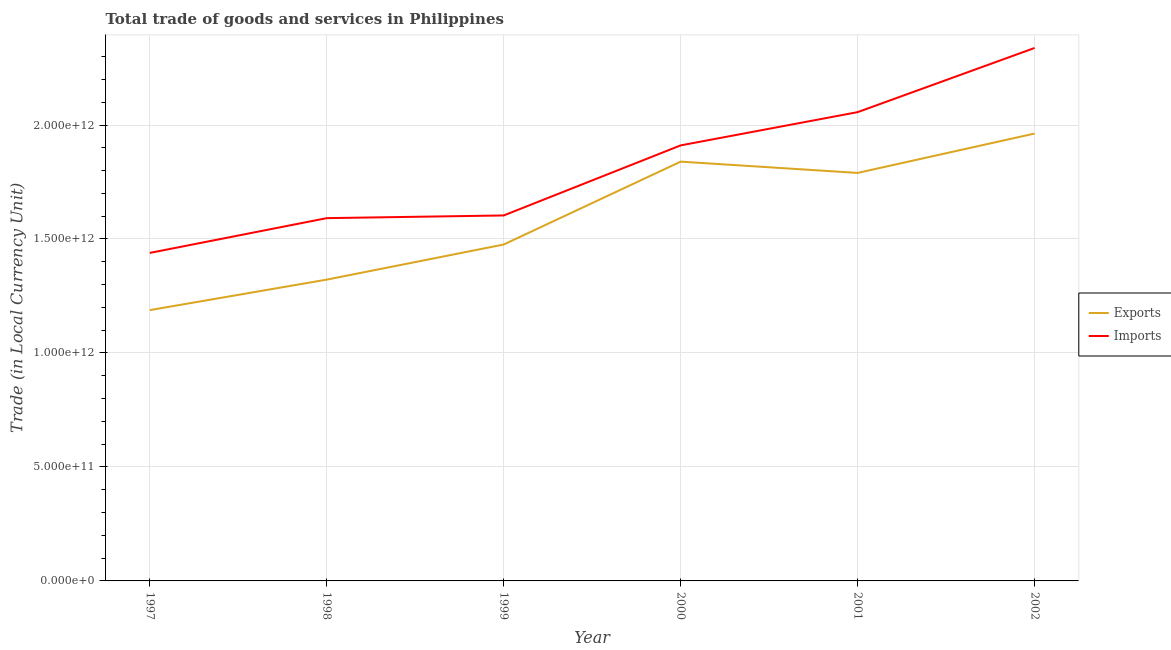How many different coloured lines are there?
Provide a short and direct response. 2. Does the line corresponding to export of goods and services intersect with the line corresponding to imports of goods and services?
Offer a terse response. No. Is the number of lines equal to the number of legend labels?
Your response must be concise. Yes. What is the imports of goods and services in 1999?
Provide a short and direct response. 1.60e+12. Across all years, what is the maximum imports of goods and services?
Provide a short and direct response. 2.34e+12. Across all years, what is the minimum export of goods and services?
Keep it short and to the point. 1.19e+12. In which year was the export of goods and services maximum?
Give a very brief answer. 2002. In which year was the export of goods and services minimum?
Your answer should be very brief. 1997. What is the total imports of goods and services in the graph?
Ensure brevity in your answer.  1.09e+13. What is the difference between the export of goods and services in 1999 and that in 2001?
Your answer should be very brief. -3.14e+11. What is the difference between the export of goods and services in 1998 and the imports of goods and services in 2002?
Your response must be concise. -1.02e+12. What is the average export of goods and services per year?
Give a very brief answer. 1.60e+12. In the year 1999, what is the difference between the export of goods and services and imports of goods and services?
Your response must be concise. -1.28e+11. In how many years, is the imports of goods and services greater than 1800000000000 LCU?
Offer a very short reply. 3. What is the ratio of the export of goods and services in 1997 to that in 2002?
Give a very brief answer. 0.61. Is the export of goods and services in 1998 less than that in 2000?
Your answer should be compact. Yes. Is the difference between the imports of goods and services in 1999 and 2001 greater than the difference between the export of goods and services in 1999 and 2001?
Give a very brief answer. No. What is the difference between the highest and the second highest imports of goods and services?
Offer a very short reply. 2.81e+11. What is the difference between the highest and the lowest imports of goods and services?
Offer a terse response. 8.99e+11. In how many years, is the export of goods and services greater than the average export of goods and services taken over all years?
Your answer should be very brief. 3. Is the imports of goods and services strictly less than the export of goods and services over the years?
Your answer should be very brief. No. What is the difference between two consecutive major ticks on the Y-axis?
Offer a very short reply. 5.00e+11. Does the graph contain any zero values?
Your answer should be very brief. No. How are the legend labels stacked?
Your response must be concise. Vertical. What is the title of the graph?
Your response must be concise. Total trade of goods and services in Philippines. Does "Import" appear as one of the legend labels in the graph?
Provide a short and direct response. No. What is the label or title of the X-axis?
Make the answer very short. Year. What is the label or title of the Y-axis?
Give a very brief answer. Trade (in Local Currency Unit). What is the Trade (in Local Currency Unit) of Exports in 1997?
Offer a very short reply. 1.19e+12. What is the Trade (in Local Currency Unit) in Imports in 1997?
Give a very brief answer. 1.44e+12. What is the Trade (in Local Currency Unit) of Exports in 1998?
Make the answer very short. 1.32e+12. What is the Trade (in Local Currency Unit) in Imports in 1998?
Give a very brief answer. 1.59e+12. What is the Trade (in Local Currency Unit) in Exports in 1999?
Your answer should be very brief. 1.48e+12. What is the Trade (in Local Currency Unit) of Imports in 1999?
Your answer should be compact. 1.60e+12. What is the Trade (in Local Currency Unit) in Exports in 2000?
Keep it short and to the point. 1.84e+12. What is the Trade (in Local Currency Unit) in Imports in 2000?
Provide a short and direct response. 1.91e+12. What is the Trade (in Local Currency Unit) of Exports in 2001?
Your answer should be compact. 1.79e+12. What is the Trade (in Local Currency Unit) in Imports in 2001?
Offer a very short reply. 2.06e+12. What is the Trade (in Local Currency Unit) of Exports in 2002?
Offer a very short reply. 1.96e+12. What is the Trade (in Local Currency Unit) in Imports in 2002?
Provide a short and direct response. 2.34e+12. Across all years, what is the maximum Trade (in Local Currency Unit) of Exports?
Offer a terse response. 1.96e+12. Across all years, what is the maximum Trade (in Local Currency Unit) in Imports?
Give a very brief answer. 2.34e+12. Across all years, what is the minimum Trade (in Local Currency Unit) in Exports?
Ensure brevity in your answer.  1.19e+12. Across all years, what is the minimum Trade (in Local Currency Unit) of Imports?
Your response must be concise. 1.44e+12. What is the total Trade (in Local Currency Unit) of Exports in the graph?
Your response must be concise. 9.58e+12. What is the total Trade (in Local Currency Unit) of Imports in the graph?
Your response must be concise. 1.09e+13. What is the difference between the Trade (in Local Currency Unit) of Exports in 1997 and that in 1998?
Your response must be concise. -1.34e+11. What is the difference between the Trade (in Local Currency Unit) in Imports in 1997 and that in 1998?
Give a very brief answer. -1.53e+11. What is the difference between the Trade (in Local Currency Unit) of Exports in 1997 and that in 1999?
Your response must be concise. -2.88e+11. What is the difference between the Trade (in Local Currency Unit) in Imports in 1997 and that in 1999?
Make the answer very short. -1.64e+11. What is the difference between the Trade (in Local Currency Unit) of Exports in 1997 and that in 2000?
Your answer should be compact. -6.51e+11. What is the difference between the Trade (in Local Currency Unit) in Imports in 1997 and that in 2000?
Provide a succinct answer. -4.72e+11. What is the difference between the Trade (in Local Currency Unit) in Exports in 1997 and that in 2001?
Ensure brevity in your answer.  -6.02e+11. What is the difference between the Trade (in Local Currency Unit) of Imports in 1997 and that in 2001?
Your response must be concise. -6.18e+11. What is the difference between the Trade (in Local Currency Unit) of Exports in 1997 and that in 2002?
Offer a very short reply. -7.75e+11. What is the difference between the Trade (in Local Currency Unit) in Imports in 1997 and that in 2002?
Provide a succinct answer. -8.99e+11. What is the difference between the Trade (in Local Currency Unit) of Exports in 1998 and that in 1999?
Offer a terse response. -1.54e+11. What is the difference between the Trade (in Local Currency Unit) of Imports in 1998 and that in 1999?
Ensure brevity in your answer.  -1.18e+1. What is the difference between the Trade (in Local Currency Unit) of Exports in 1998 and that in 2000?
Provide a short and direct response. -5.18e+11. What is the difference between the Trade (in Local Currency Unit) in Imports in 1998 and that in 2000?
Offer a terse response. -3.19e+11. What is the difference between the Trade (in Local Currency Unit) in Exports in 1998 and that in 2001?
Offer a terse response. -4.68e+11. What is the difference between the Trade (in Local Currency Unit) of Imports in 1998 and that in 2001?
Make the answer very short. -4.65e+11. What is the difference between the Trade (in Local Currency Unit) in Exports in 1998 and that in 2002?
Keep it short and to the point. -6.41e+11. What is the difference between the Trade (in Local Currency Unit) of Imports in 1998 and that in 2002?
Provide a short and direct response. -7.46e+11. What is the difference between the Trade (in Local Currency Unit) in Exports in 1999 and that in 2000?
Your answer should be very brief. -3.64e+11. What is the difference between the Trade (in Local Currency Unit) in Imports in 1999 and that in 2000?
Make the answer very short. -3.07e+11. What is the difference between the Trade (in Local Currency Unit) in Exports in 1999 and that in 2001?
Give a very brief answer. -3.14e+11. What is the difference between the Trade (in Local Currency Unit) of Imports in 1999 and that in 2001?
Make the answer very short. -4.53e+11. What is the difference between the Trade (in Local Currency Unit) of Exports in 1999 and that in 2002?
Keep it short and to the point. -4.87e+11. What is the difference between the Trade (in Local Currency Unit) in Imports in 1999 and that in 2002?
Provide a succinct answer. -7.35e+11. What is the difference between the Trade (in Local Currency Unit) of Exports in 2000 and that in 2001?
Your answer should be compact. 4.95e+1. What is the difference between the Trade (in Local Currency Unit) in Imports in 2000 and that in 2001?
Offer a terse response. -1.46e+11. What is the difference between the Trade (in Local Currency Unit) of Exports in 2000 and that in 2002?
Give a very brief answer. -1.23e+11. What is the difference between the Trade (in Local Currency Unit) of Imports in 2000 and that in 2002?
Offer a very short reply. -4.27e+11. What is the difference between the Trade (in Local Currency Unit) of Exports in 2001 and that in 2002?
Your answer should be compact. -1.73e+11. What is the difference between the Trade (in Local Currency Unit) in Imports in 2001 and that in 2002?
Offer a terse response. -2.81e+11. What is the difference between the Trade (in Local Currency Unit) in Exports in 1997 and the Trade (in Local Currency Unit) in Imports in 1998?
Offer a terse response. -4.03e+11. What is the difference between the Trade (in Local Currency Unit) of Exports in 1997 and the Trade (in Local Currency Unit) of Imports in 1999?
Your answer should be compact. -4.15e+11. What is the difference between the Trade (in Local Currency Unit) in Exports in 1997 and the Trade (in Local Currency Unit) in Imports in 2000?
Give a very brief answer. -7.23e+11. What is the difference between the Trade (in Local Currency Unit) of Exports in 1997 and the Trade (in Local Currency Unit) of Imports in 2001?
Your answer should be very brief. -8.68e+11. What is the difference between the Trade (in Local Currency Unit) in Exports in 1997 and the Trade (in Local Currency Unit) in Imports in 2002?
Your answer should be compact. -1.15e+12. What is the difference between the Trade (in Local Currency Unit) of Exports in 1998 and the Trade (in Local Currency Unit) of Imports in 1999?
Ensure brevity in your answer.  -2.82e+11. What is the difference between the Trade (in Local Currency Unit) of Exports in 1998 and the Trade (in Local Currency Unit) of Imports in 2000?
Keep it short and to the point. -5.89e+11. What is the difference between the Trade (in Local Currency Unit) of Exports in 1998 and the Trade (in Local Currency Unit) of Imports in 2001?
Ensure brevity in your answer.  -7.35e+11. What is the difference between the Trade (in Local Currency Unit) in Exports in 1998 and the Trade (in Local Currency Unit) in Imports in 2002?
Your answer should be compact. -1.02e+12. What is the difference between the Trade (in Local Currency Unit) in Exports in 1999 and the Trade (in Local Currency Unit) in Imports in 2000?
Offer a terse response. -4.35e+11. What is the difference between the Trade (in Local Currency Unit) of Exports in 1999 and the Trade (in Local Currency Unit) of Imports in 2001?
Offer a very short reply. -5.81e+11. What is the difference between the Trade (in Local Currency Unit) of Exports in 1999 and the Trade (in Local Currency Unit) of Imports in 2002?
Your answer should be compact. -8.62e+11. What is the difference between the Trade (in Local Currency Unit) of Exports in 2000 and the Trade (in Local Currency Unit) of Imports in 2001?
Provide a succinct answer. -2.17e+11. What is the difference between the Trade (in Local Currency Unit) of Exports in 2000 and the Trade (in Local Currency Unit) of Imports in 2002?
Your response must be concise. -4.99e+11. What is the difference between the Trade (in Local Currency Unit) in Exports in 2001 and the Trade (in Local Currency Unit) in Imports in 2002?
Your answer should be very brief. -5.48e+11. What is the average Trade (in Local Currency Unit) of Exports per year?
Your answer should be very brief. 1.60e+12. What is the average Trade (in Local Currency Unit) in Imports per year?
Keep it short and to the point. 1.82e+12. In the year 1997, what is the difference between the Trade (in Local Currency Unit) of Exports and Trade (in Local Currency Unit) of Imports?
Your answer should be compact. -2.51e+11. In the year 1998, what is the difference between the Trade (in Local Currency Unit) of Exports and Trade (in Local Currency Unit) of Imports?
Your response must be concise. -2.70e+11. In the year 1999, what is the difference between the Trade (in Local Currency Unit) of Exports and Trade (in Local Currency Unit) of Imports?
Your answer should be very brief. -1.28e+11. In the year 2000, what is the difference between the Trade (in Local Currency Unit) in Exports and Trade (in Local Currency Unit) in Imports?
Give a very brief answer. -7.13e+1. In the year 2001, what is the difference between the Trade (in Local Currency Unit) in Exports and Trade (in Local Currency Unit) in Imports?
Your answer should be very brief. -2.67e+11. In the year 2002, what is the difference between the Trade (in Local Currency Unit) of Exports and Trade (in Local Currency Unit) of Imports?
Keep it short and to the point. -3.75e+11. What is the ratio of the Trade (in Local Currency Unit) in Exports in 1997 to that in 1998?
Offer a very short reply. 0.9. What is the ratio of the Trade (in Local Currency Unit) in Imports in 1997 to that in 1998?
Offer a very short reply. 0.9. What is the ratio of the Trade (in Local Currency Unit) of Exports in 1997 to that in 1999?
Provide a succinct answer. 0.81. What is the ratio of the Trade (in Local Currency Unit) in Imports in 1997 to that in 1999?
Make the answer very short. 0.9. What is the ratio of the Trade (in Local Currency Unit) of Exports in 1997 to that in 2000?
Provide a succinct answer. 0.65. What is the ratio of the Trade (in Local Currency Unit) in Imports in 1997 to that in 2000?
Your answer should be compact. 0.75. What is the ratio of the Trade (in Local Currency Unit) of Exports in 1997 to that in 2001?
Provide a short and direct response. 0.66. What is the ratio of the Trade (in Local Currency Unit) of Imports in 1997 to that in 2001?
Keep it short and to the point. 0.7. What is the ratio of the Trade (in Local Currency Unit) in Exports in 1997 to that in 2002?
Keep it short and to the point. 0.61. What is the ratio of the Trade (in Local Currency Unit) in Imports in 1997 to that in 2002?
Your response must be concise. 0.62. What is the ratio of the Trade (in Local Currency Unit) in Exports in 1998 to that in 1999?
Provide a succinct answer. 0.9. What is the ratio of the Trade (in Local Currency Unit) of Exports in 1998 to that in 2000?
Offer a very short reply. 0.72. What is the ratio of the Trade (in Local Currency Unit) in Imports in 1998 to that in 2000?
Ensure brevity in your answer.  0.83. What is the ratio of the Trade (in Local Currency Unit) in Exports in 1998 to that in 2001?
Your response must be concise. 0.74. What is the ratio of the Trade (in Local Currency Unit) of Imports in 1998 to that in 2001?
Make the answer very short. 0.77. What is the ratio of the Trade (in Local Currency Unit) of Exports in 1998 to that in 2002?
Offer a very short reply. 0.67. What is the ratio of the Trade (in Local Currency Unit) of Imports in 1998 to that in 2002?
Provide a short and direct response. 0.68. What is the ratio of the Trade (in Local Currency Unit) in Exports in 1999 to that in 2000?
Offer a very short reply. 0.8. What is the ratio of the Trade (in Local Currency Unit) of Imports in 1999 to that in 2000?
Offer a terse response. 0.84. What is the ratio of the Trade (in Local Currency Unit) of Exports in 1999 to that in 2001?
Ensure brevity in your answer.  0.82. What is the ratio of the Trade (in Local Currency Unit) in Imports in 1999 to that in 2001?
Provide a short and direct response. 0.78. What is the ratio of the Trade (in Local Currency Unit) of Exports in 1999 to that in 2002?
Keep it short and to the point. 0.75. What is the ratio of the Trade (in Local Currency Unit) of Imports in 1999 to that in 2002?
Provide a succinct answer. 0.69. What is the ratio of the Trade (in Local Currency Unit) in Exports in 2000 to that in 2001?
Offer a very short reply. 1.03. What is the ratio of the Trade (in Local Currency Unit) of Imports in 2000 to that in 2001?
Keep it short and to the point. 0.93. What is the ratio of the Trade (in Local Currency Unit) of Exports in 2000 to that in 2002?
Ensure brevity in your answer.  0.94. What is the ratio of the Trade (in Local Currency Unit) of Imports in 2000 to that in 2002?
Your response must be concise. 0.82. What is the ratio of the Trade (in Local Currency Unit) in Exports in 2001 to that in 2002?
Your response must be concise. 0.91. What is the ratio of the Trade (in Local Currency Unit) of Imports in 2001 to that in 2002?
Your answer should be very brief. 0.88. What is the difference between the highest and the second highest Trade (in Local Currency Unit) in Exports?
Offer a terse response. 1.23e+11. What is the difference between the highest and the second highest Trade (in Local Currency Unit) in Imports?
Keep it short and to the point. 2.81e+11. What is the difference between the highest and the lowest Trade (in Local Currency Unit) of Exports?
Make the answer very short. 7.75e+11. What is the difference between the highest and the lowest Trade (in Local Currency Unit) of Imports?
Provide a short and direct response. 8.99e+11. 